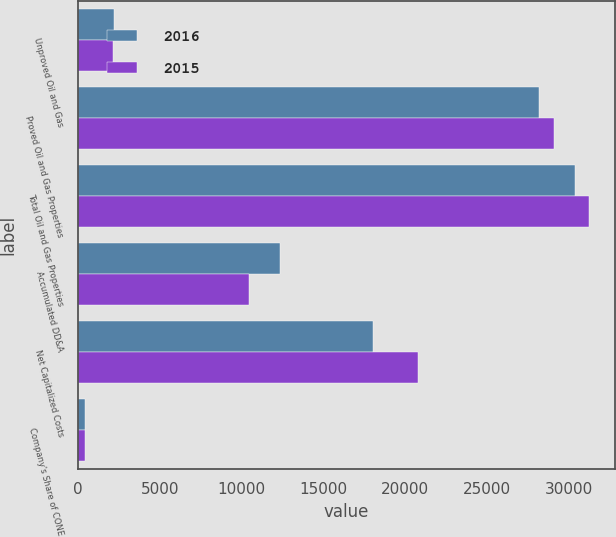<chart> <loc_0><loc_0><loc_500><loc_500><stacked_bar_chart><ecel><fcel>Unproved Oil and Gas<fcel>Proved Oil and Gas Properties<fcel>Total Oil and Gas Properties<fcel>Accumulated DD&A<fcel>Net Capitalized Costs<fcel>Company's Share of CONE<nl><fcel>2016<fcel>2197<fcel>28158<fcel>30355<fcel>12325<fcel>18030<fcel>440<nl><fcel>2015<fcel>2151<fcel>29069<fcel>31220<fcel>10439<fcel>20781<fcel>433<nl></chart> 